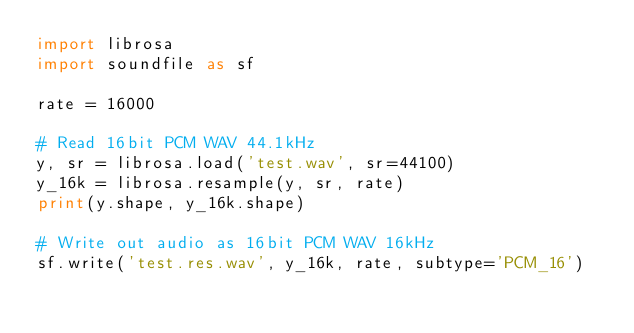Convert code to text. <code><loc_0><loc_0><loc_500><loc_500><_Python_>import librosa
import soundfile as sf

rate = 16000

# Read 16bit PCM WAV 44.1kHz
y, sr = librosa.load('test.wav', sr=44100)
y_16k = librosa.resample(y, sr, rate)
print(y.shape, y_16k.shape)

# Write out audio as 16bit PCM WAV 16kHz
sf.write('test.res.wav', y_16k, rate, subtype='PCM_16')</code> 